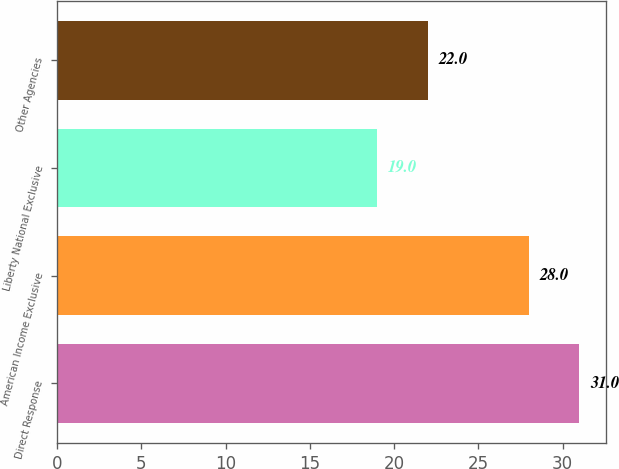Convert chart to OTSL. <chart><loc_0><loc_0><loc_500><loc_500><bar_chart><fcel>Direct Response<fcel>American Income Exclusive<fcel>Liberty National Exclusive<fcel>Other Agencies<nl><fcel>31<fcel>28<fcel>19<fcel>22<nl></chart> 